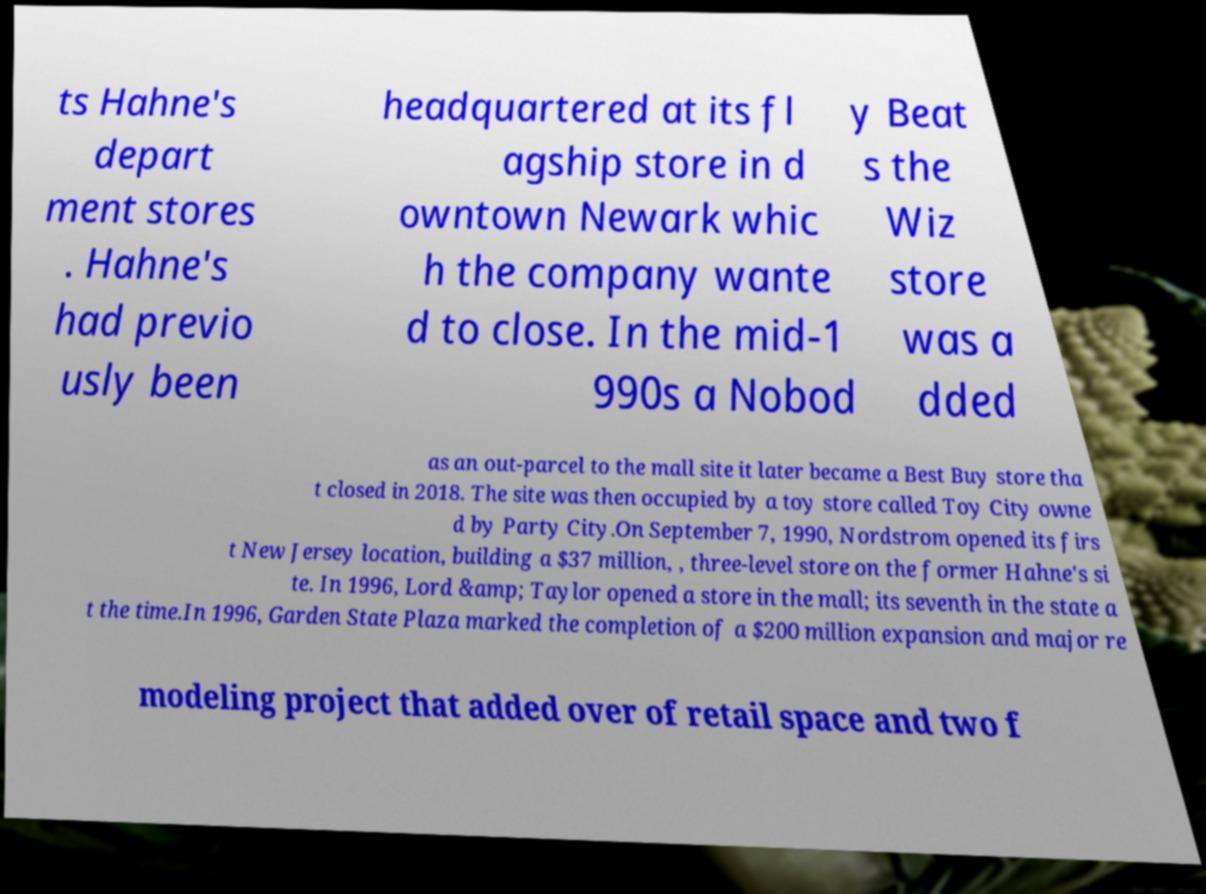I need the written content from this picture converted into text. Can you do that? ts Hahne's depart ment stores . Hahne's had previo usly been headquartered at its fl agship store in d owntown Newark whic h the company wante d to close. In the mid-1 990s a Nobod y Beat s the Wiz store was a dded as an out-parcel to the mall site it later became a Best Buy store tha t closed in 2018. The site was then occupied by a toy store called Toy City owne d by Party City.On September 7, 1990, Nordstrom opened its firs t New Jersey location, building a $37 million, , three-level store on the former Hahne's si te. In 1996, Lord &amp; Taylor opened a store in the mall; its seventh in the state a t the time.In 1996, Garden State Plaza marked the completion of a $200 million expansion and major re modeling project that added over of retail space and two f 